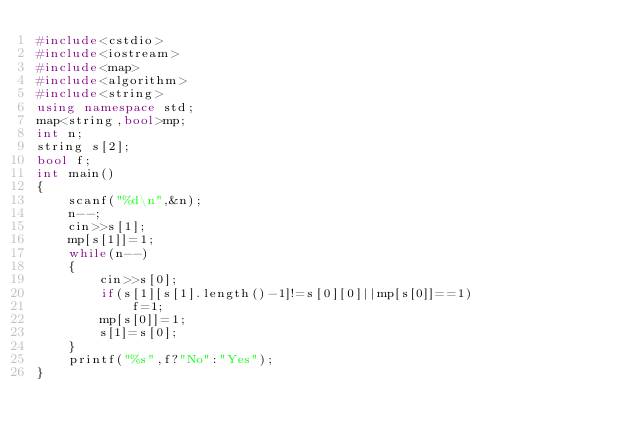Convert code to text. <code><loc_0><loc_0><loc_500><loc_500><_C++_>#include<cstdio>
#include<iostream>
#include<map>
#include<algorithm>
#include<string>
using namespace std;
map<string,bool>mp;
int n;
string s[2];
bool f;
int main()
{
	scanf("%d\n",&n);
	n--;
	cin>>s[1];
	mp[s[1]]=1;
	while(n--)
	{
		cin>>s[0];
		if(s[1][s[1].length()-1]!=s[0][0]||mp[s[0]]==1)
			f=1;
		mp[s[0]]=1;
		s[1]=s[0];
	}
	printf("%s",f?"No":"Yes");
}</code> 